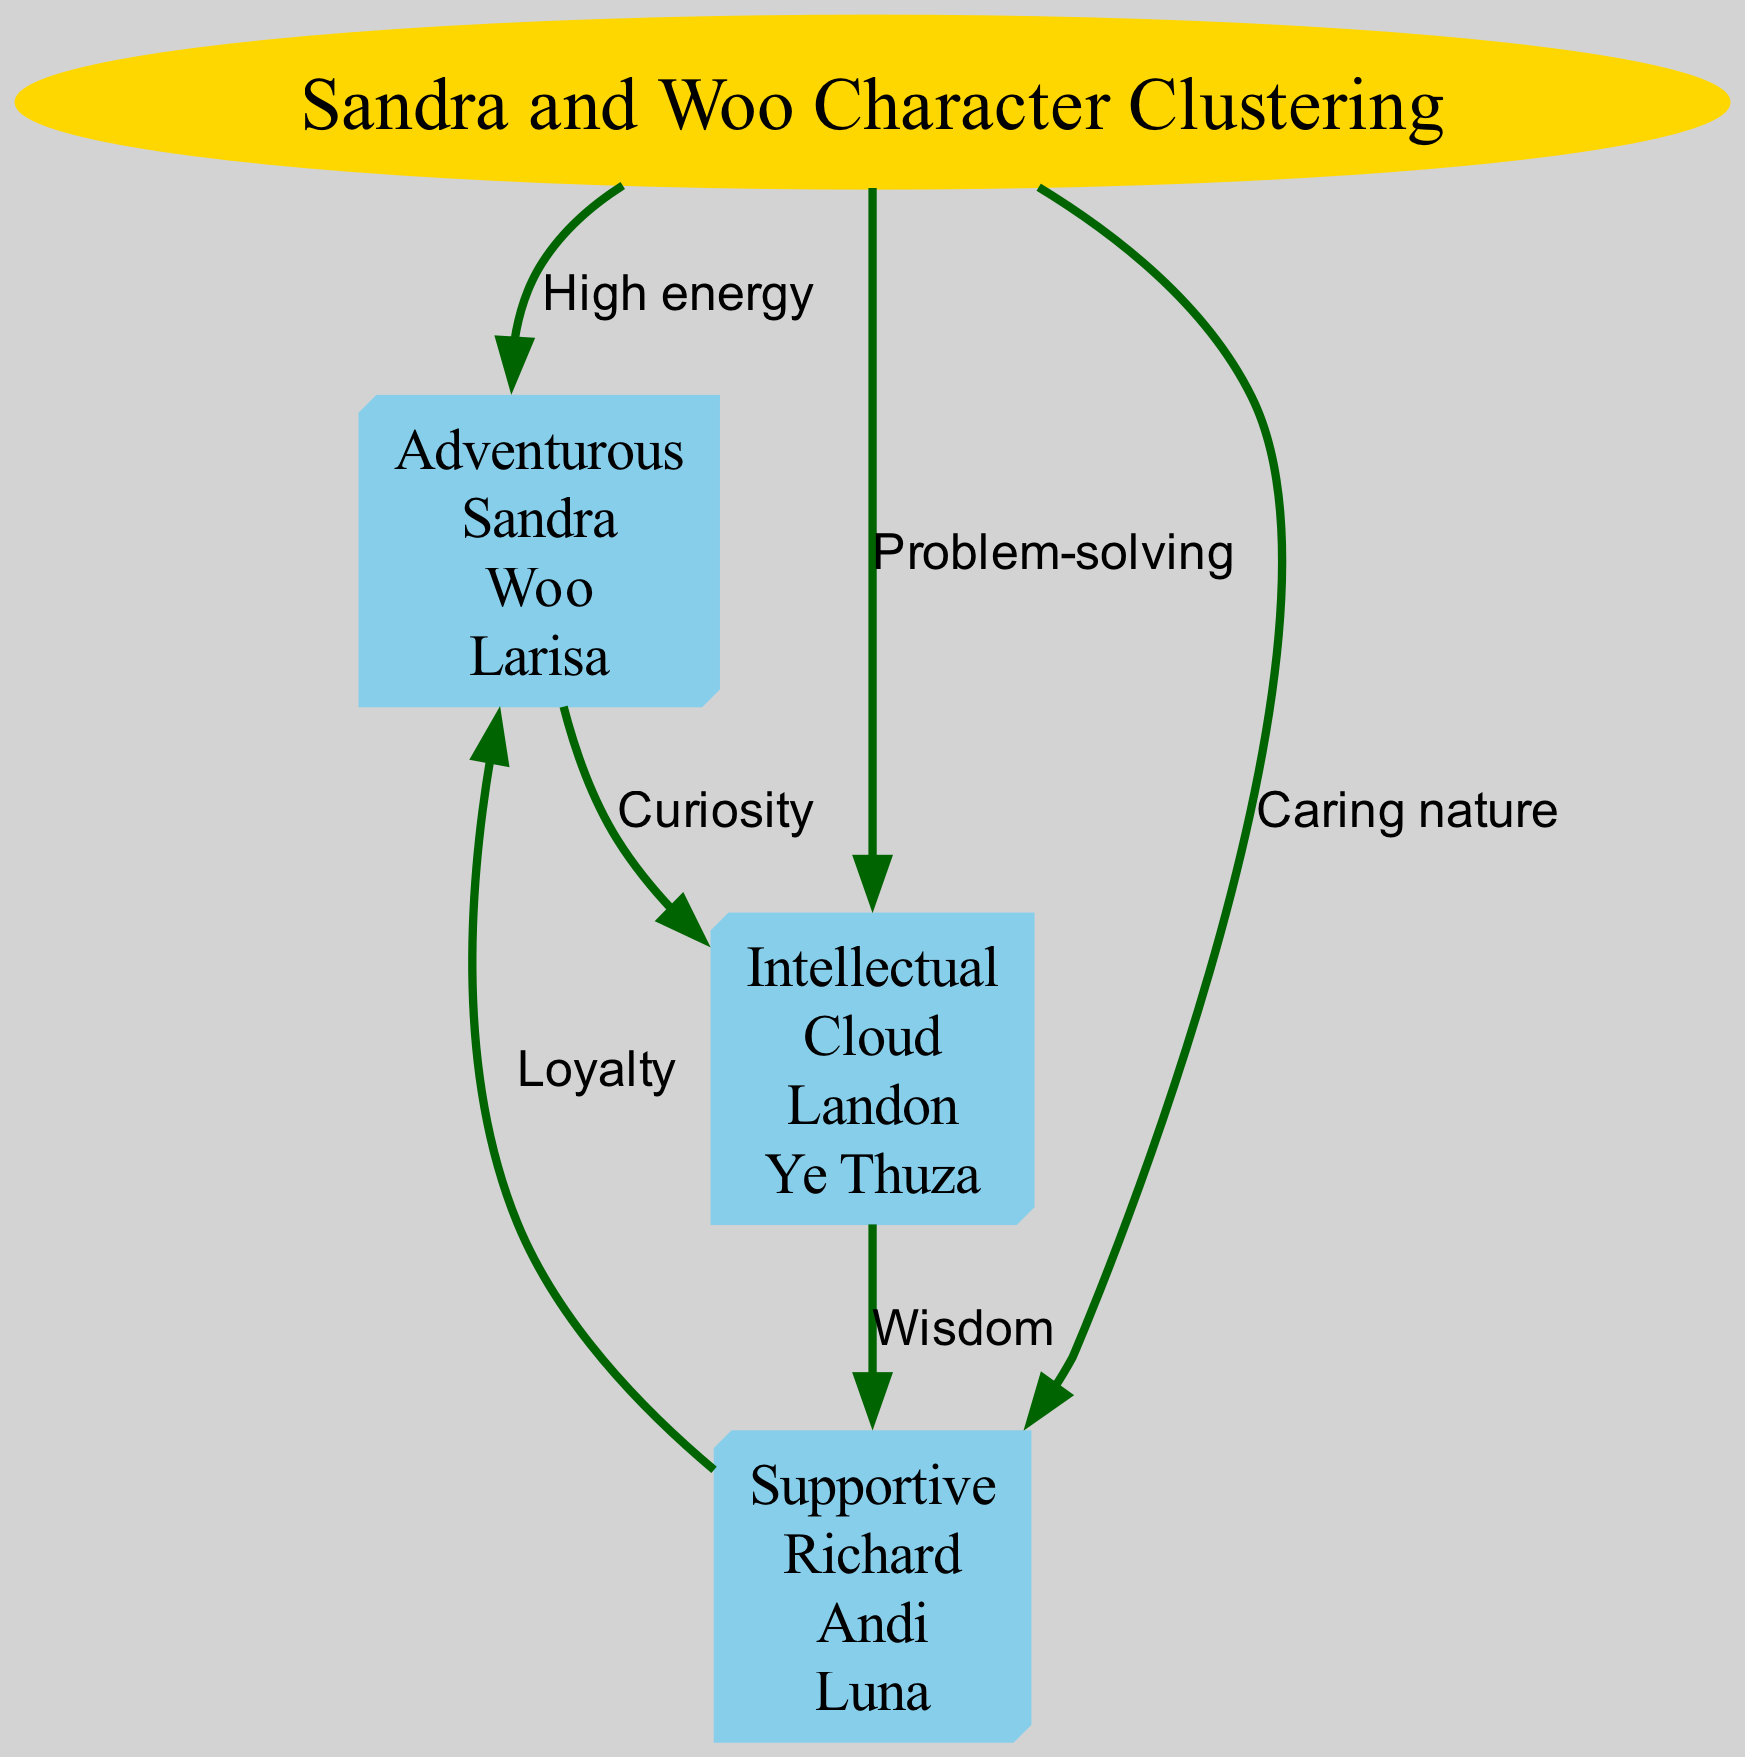What's the main topic of the diagram? The main topic is indicated by the label of the root node, which is "Sandra and Woo Character Clustering". This is where the title of the diagram resides, focusing on the clustering of characters from the "Sandra and Woo" series based on personality traits.
Answer: Sandra and Woo Character Clustering How many personality trait groups are shown? There are three groups visually represented in the diagram, which can be counted from the nodes labeled as "Adventurous", "Intellectual", and "Supportive".
Answer: 3 Which characters belong to the "Intellectual" group? The "Intellectual" group contains the characters listed under that node, which are "Cloud", "Landon", and "Ye Thuza". This information is found directly associated with the "Intellectual" node.
Answer: Cloud, Landon, Ye Thuza What relationship is labeled between "group1" and "group2"? The edge connecting "group1" (Adventurous) and "group2" (Intellectual) is labeled "Curiosity". This can be traced by examining the connecting edge and its corresponding label in the diagram.
Answer: Curiosity Which group has a direct edge relationship with "group3"? The "Supportive" group (group3) has direct edges going to both "group1" (Adventurous) and "group2" (Intellectual). However, the question specifies "group3" itself, which shows a direct relationship with both groups 1 and 2.
Answer: group1, group2 What quality connects "Adventurous" to "Supportive"? The connecting label between "Adventurous" and "Supportive" is "Loyalty". This edge can be observed directly on the diagram connecting those two groups.
Answer: Loyalty Which character is in the "Adventurous" group that also has a loyalty connection? "Woo" is the character in the "Adventurous" group that relates to the loyalty connection. This can be inferred as "Woo" is included under the group labeled "Adventurous".
Answer: Woo What qualities are shared between "Intellectual" and "Supportive" groups? The shared quality between the "Intellectual" and "Supportive" groups through the labeled edge is "Wisdom". This is determined by examining the edge label connecting these two nodes.
Answer: Wisdom How are "group1" and "group3" related in terms of personality traits? They are related through the edge labeled "Loyalty", indicating a connection based on this trait. Examining the diagram shows this relationship between the two groups distinctly labeled.
Answer: Loyalty 